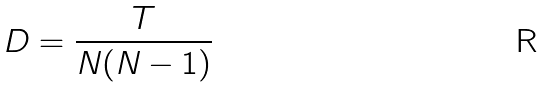Convert formula to latex. <formula><loc_0><loc_0><loc_500><loc_500>D = \frac { T } { N ( N - 1 ) }</formula> 